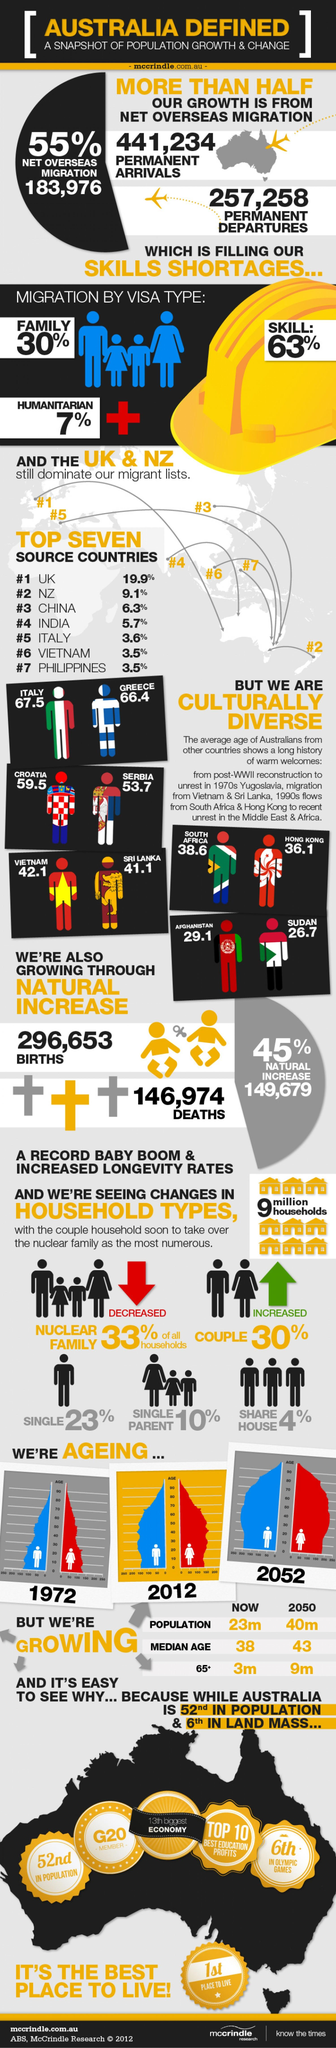Outline some significant characteristics in this image. The number of permanent arrivals is higher than the number of permanent departures. The type of household that has increased is couples. According to a study, 63% of migrations are due to the type of visa known as a skilled visa. The family migration visa type is the second highest form of migration. The graph that shows the lowest number of people above 80 is from 1972. 